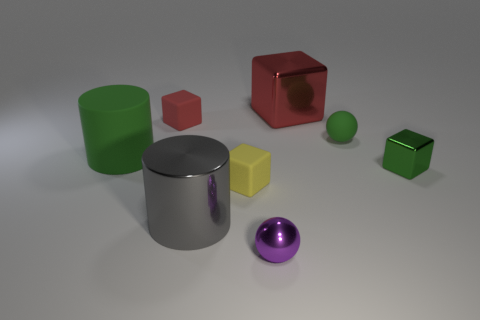Is the small metal block the same color as the rubber cylinder?
Ensure brevity in your answer.  Yes. Is there any other thing that is the same color as the small matte sphere?
Give a very brief answer. Yes. There is a tiny matte object that is the same color as the tiny shiny cube; what shape is it?
Your answer should be compact. Sphere. Are any tiny matte things visible?
Keep it short and to the point. Yes. How many cyan rubber spheres have the same size as the purple object?
Make the answer very short. 0. What number of shiny things are in front of the small shiny cube and behind the green rubber ball?
Your response must be concise. 0. There is a cylinder that is behind the green shiny thing; is it the same size as the yellow cube?
Offer a terse response. No. Is there a matte ball of the same color as the matte cylinder?
Your response must be concise. Yes. There is a green object that is made of the same material as the purple ball; what size is it?
Your answer should be compact. Small. Is the number of matte spheres behind the yellow matte block greater than the number of tiny spheres left of the rubber cylinder?
Offer a terse response. Yes. 